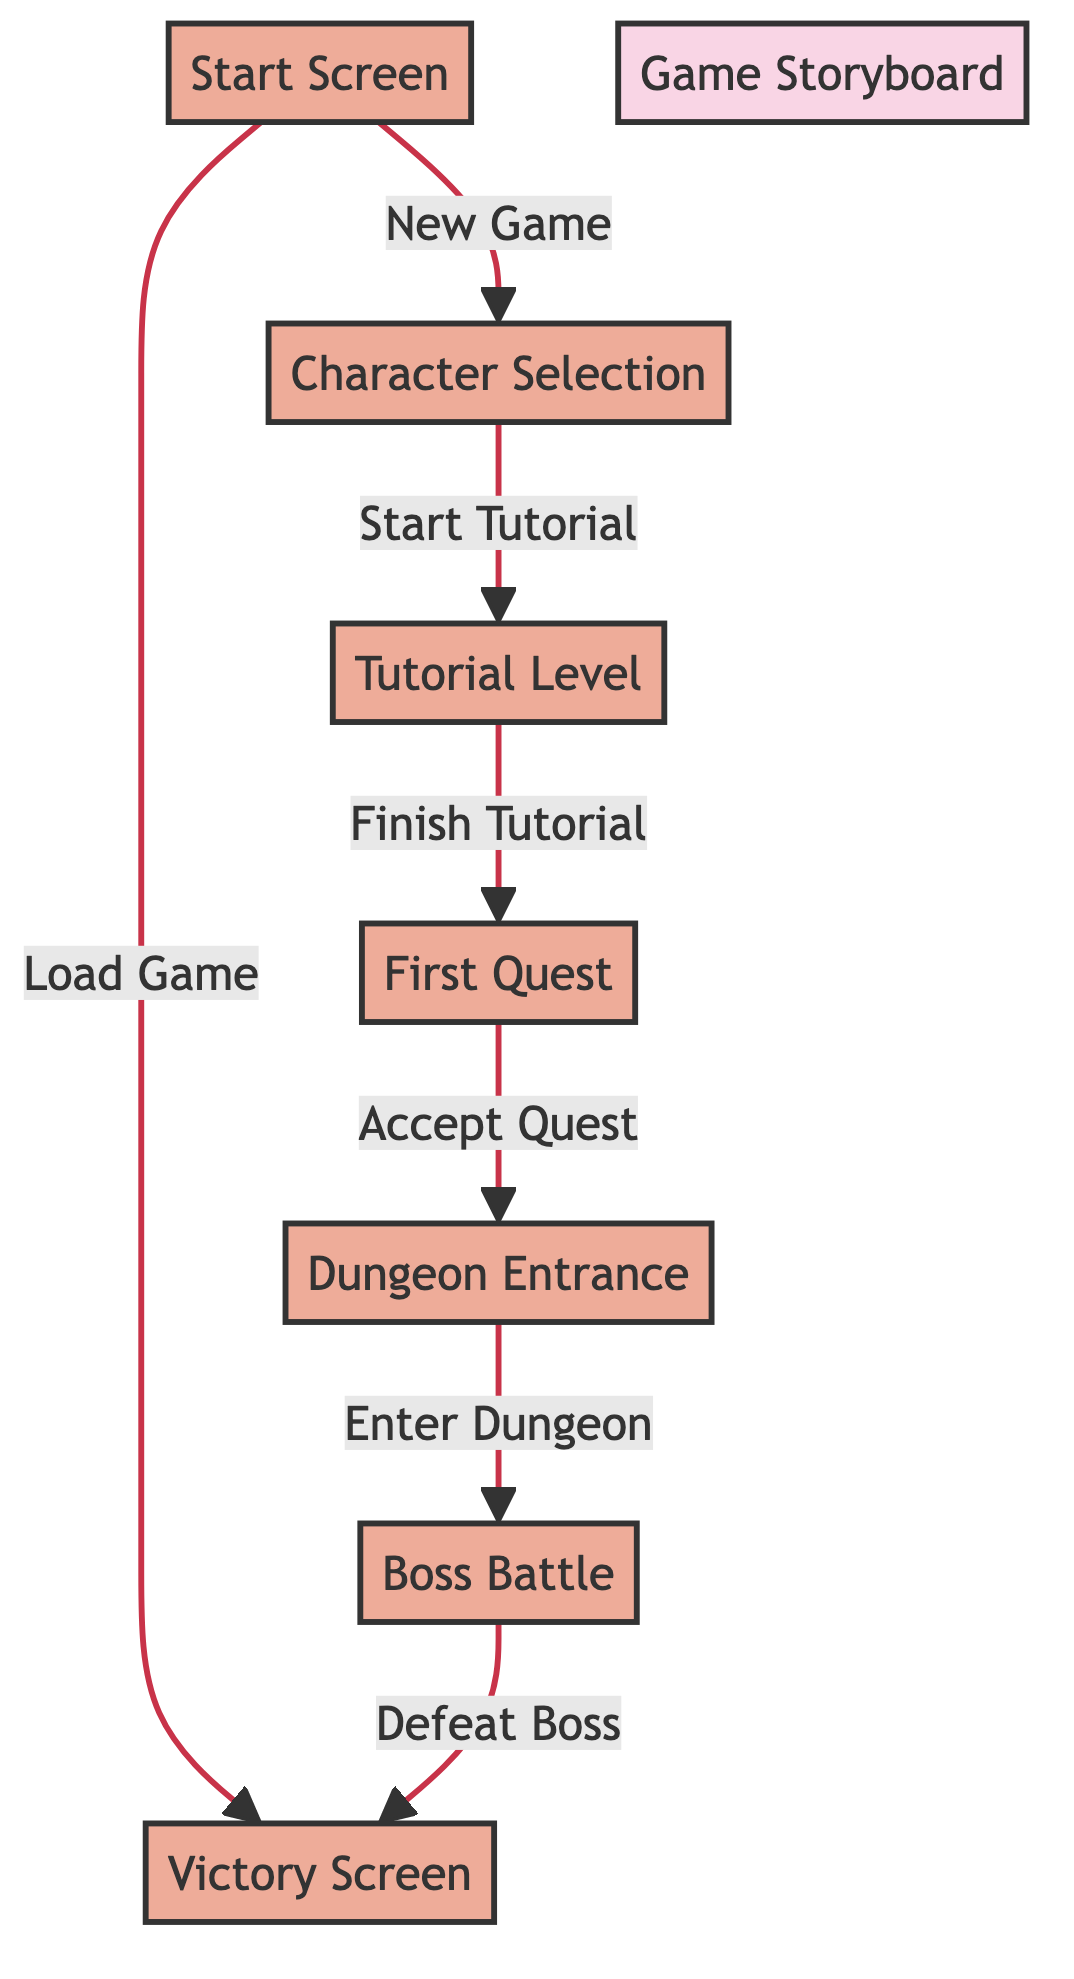What is the first scene in the game storyboard? The first scene is labeled "Start Screen," making it the initial point of the gameplay sequence.
Answer: Start Screen How many scenes are there in total? By counting the nodes in the diagram, there are a total of seven distinct scenes.
Answer: 7 What action leads from the Start Screen to the Character Selection? The action that connects these two scenes is "New Game," indicating the player's choice to start a new experience.
Answer: New Game Which scene follows the Tutorial Level? After completing the Tutorial Level, the next scene is the "First Quest," which indicates progression in the game's story.
Answer: First Quest What is the final scene of the game storyboard? The final scene in the sequence is labeled "Victory Screen," showing the end of the gameplay experience after defeating the boss.
Answer: Victory Screen What are the two actions that can be taken from the Start Screen? The two actions available from the Start Screen are "New Game" and "Load Game," leading to different paths in the game.
Answer: New Game, Load Game What is the required action to enter the Dungeon? To enter the Dungeon, the required action is "Enter Dungeon," which comes after accepting the quest.
Answer: Enter Dungeon How does one progress from the Boss Battle to the Victory Screen? The progression from the Boss Battle to the Victory Screen happens after successfully completing the action "Defeat Boss."
Answer: Defeat Boss What is the relationship between Character Selection and the Tutorial Level? The relationship is that the scene "Character Selection" leads directly to the "Tutorial Level" through the action labeled "Start Tutorial."
Answer: Start Tutorial 